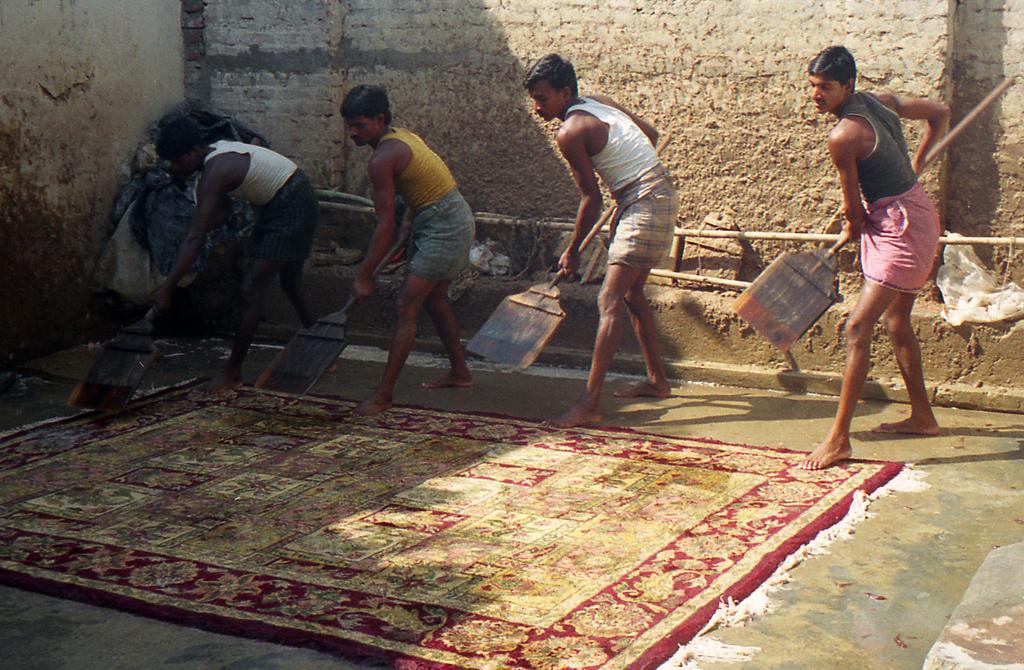How would you summarize this image in a sentence or two? In this picture it looks like 4 people holding brooms and cleaning the carpet on the ground. 